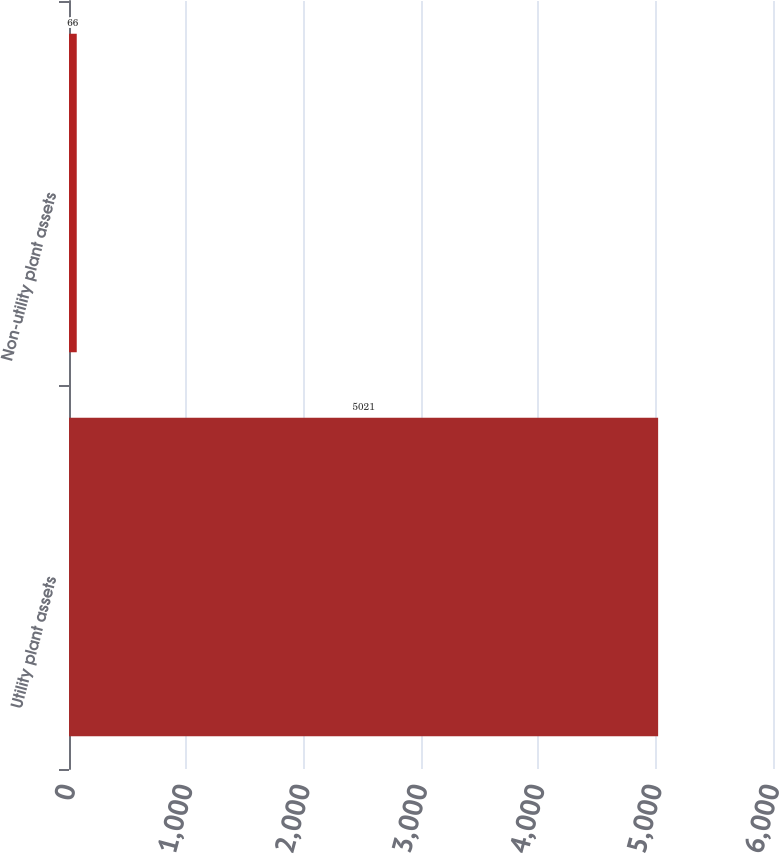Convert chart to OTSL. <chart><loc_0><loc_0><loc_500><loc_500><bar_chart><fcel>Utility plant assets<fcel>Non-utility plant assets<nl><fcel>5021<fcel>66<nl></chart> 